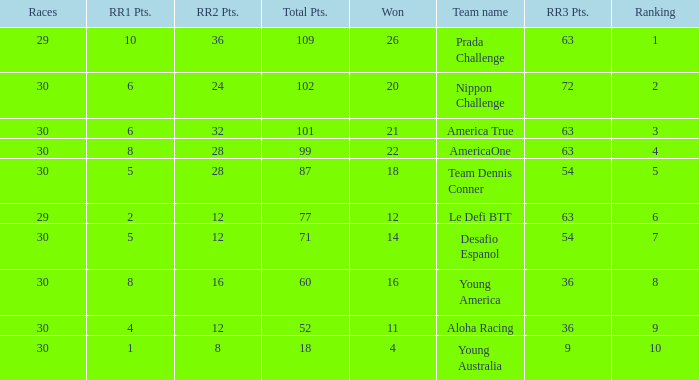Identify the rank of rr2 points when equal to 10.0. 